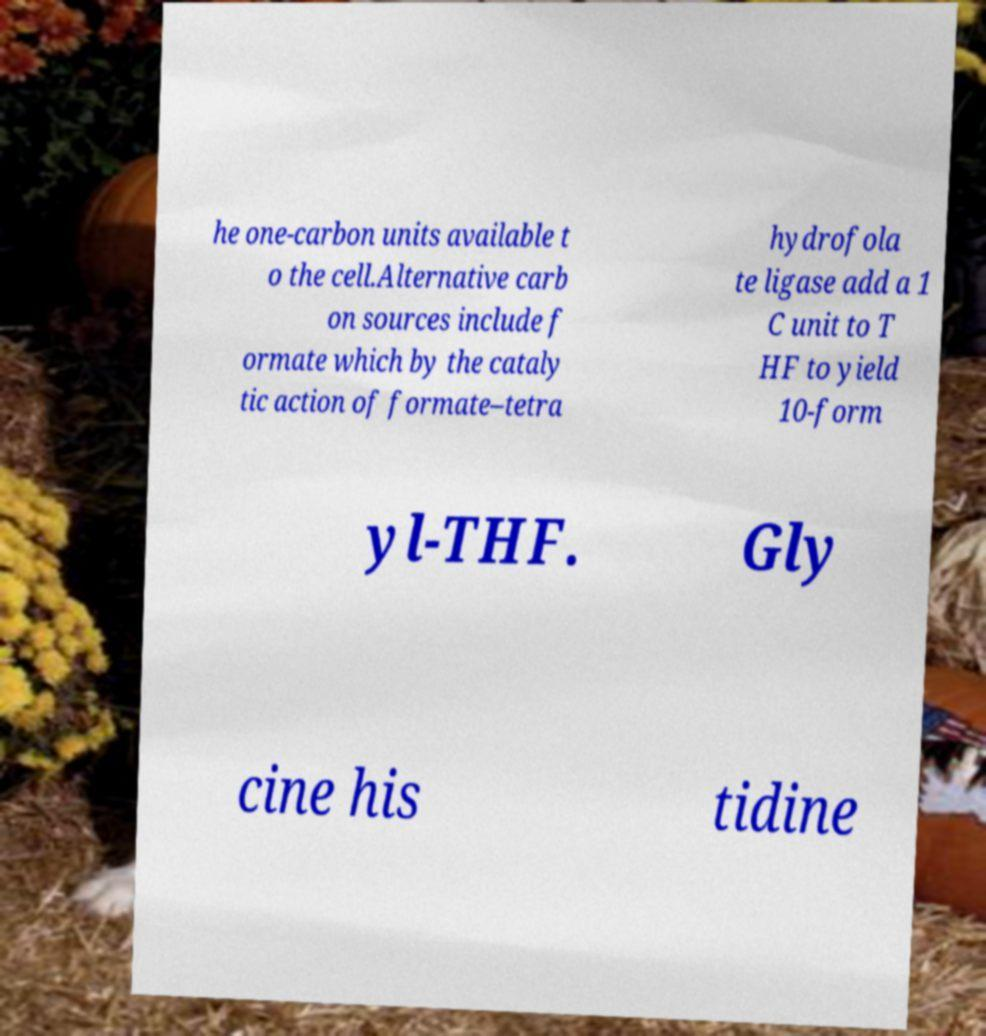Can you read and provide the text displayed in the image?This photo seems to have some interesting text. Can you extract and type it out for me? he one-carbon units available t o the cell.Alternative carb on sources include f ormate which by the cataly tic action of formate–tetra hydrofola te ligase add a 1 C unit to T HF to yield 10-form yl-THF. Gly cine his tidine 